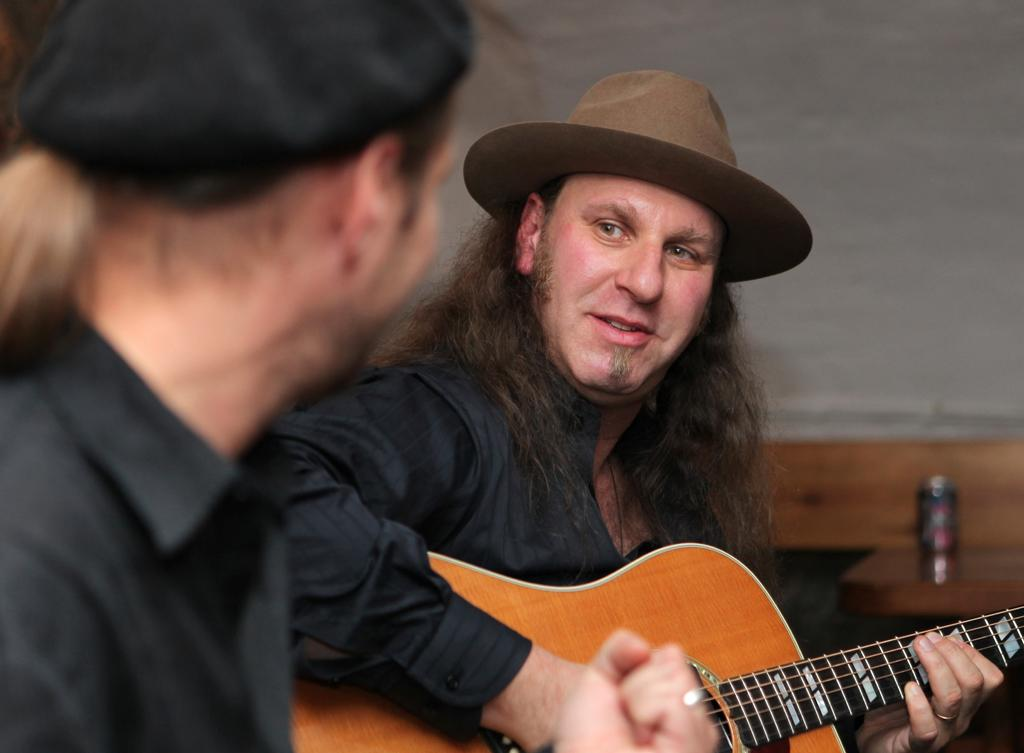What is the person in the image wearing on their head? The person in the image is wearing a brown hat. What activity is the person with the brown hat engaged in? The person with the brown hat is playing a guitar. Can you describe the other person in the image? There is another person sitting beside the person playing the guitar, but no information is provided about their role or relationship. What type of medical advice is the doctor giving to the person playing the guitar in the image? There is no doctor present in the image, so no medical advice can be given. 